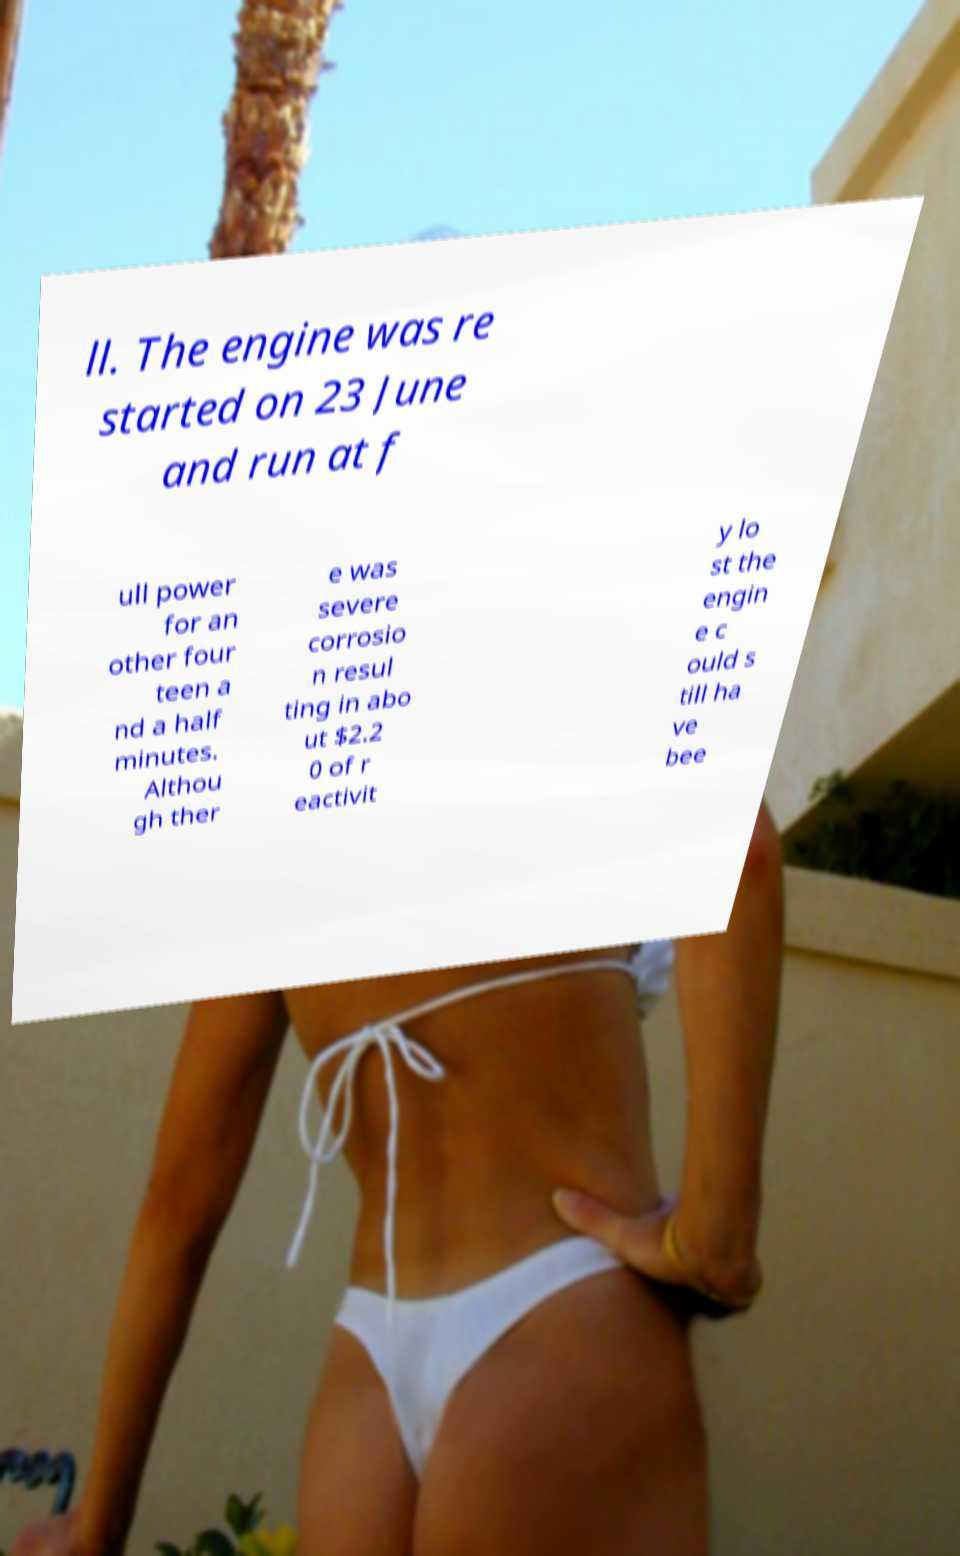Could you extract and type out the text from this image? ll. The engine was re started on 23 June and run at f ull power for an other four teen a nd a half minutes. Althou gh ther e was severe corrosio n resul ting in abo ut $2.2 0 of r eactivit y lo st the engin e c ould s till ha ve bee 